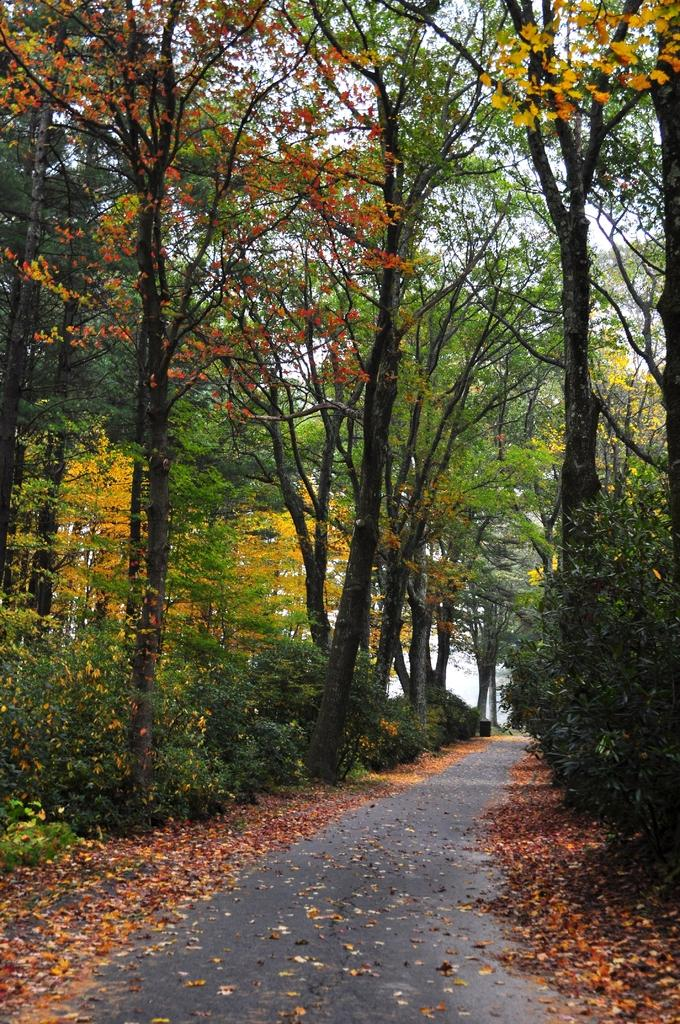What is present on the road in the image? There are dried leaves on the road in the image. What can be seen in the background of the image? There are trees and the sky visible in the background of the image. How many people are present in the crowd in the image? There is no crowd present in the image; it features dried leaves on the road and trees in the background. 